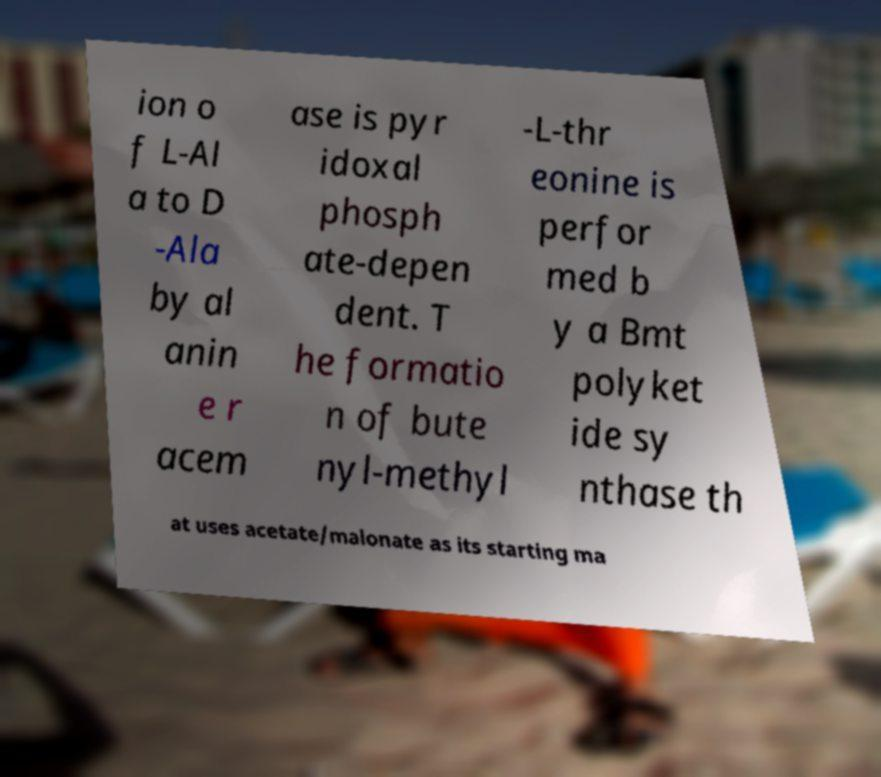Could you extract and type out the text from this image? ion o f L-Al a to D -Ala by al anin e r acem ase is pyr idoxal phosph ate-depen dent. T he formatio n of bute nyl-methyl -L-thr eonine is perfor med b y a Bmt polyket ide sy nthase th at uses acetate/malonate as its starting ma 